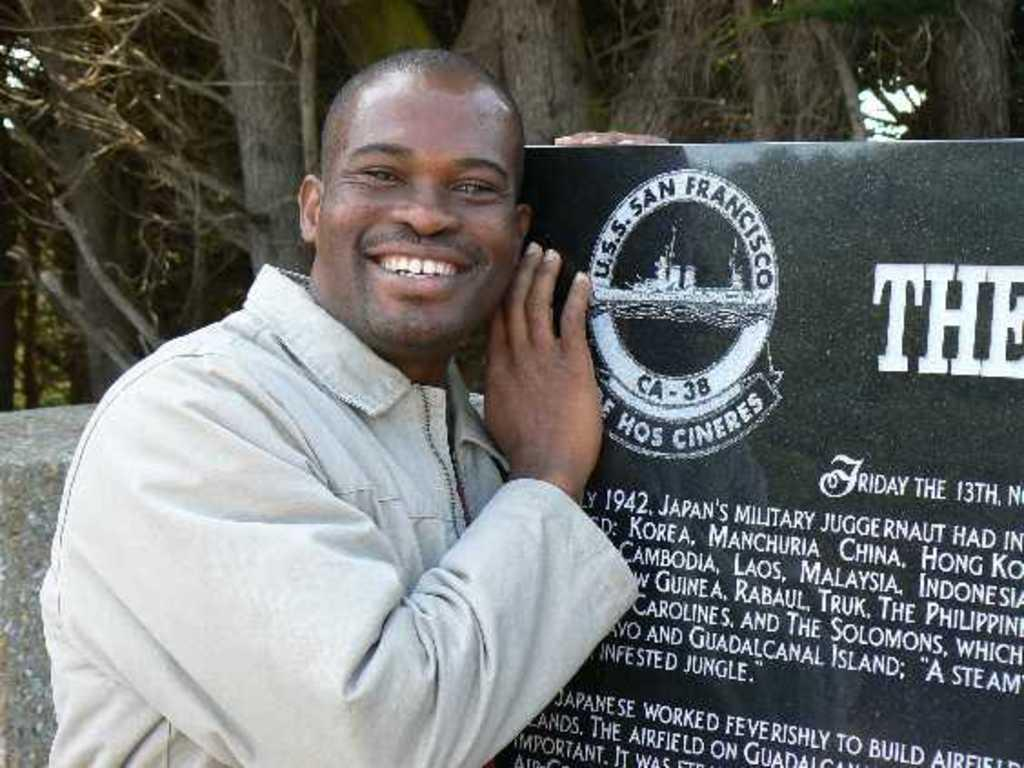What is the person in the image doing? The person is standing, laughing, and posing for the picture. What is the person holding in their hand? The person is holding a board with text on it. Which hand is the person using to hold the board? The person is holding the board in their right hand. What can be seen in the background of the image? There are trees and a wall visible in the background of the image. What type of oil can be seen dripping from the top of the person's head in the image? There is no oil present in the image, nor is there any indication of it dripping from the person's head. 